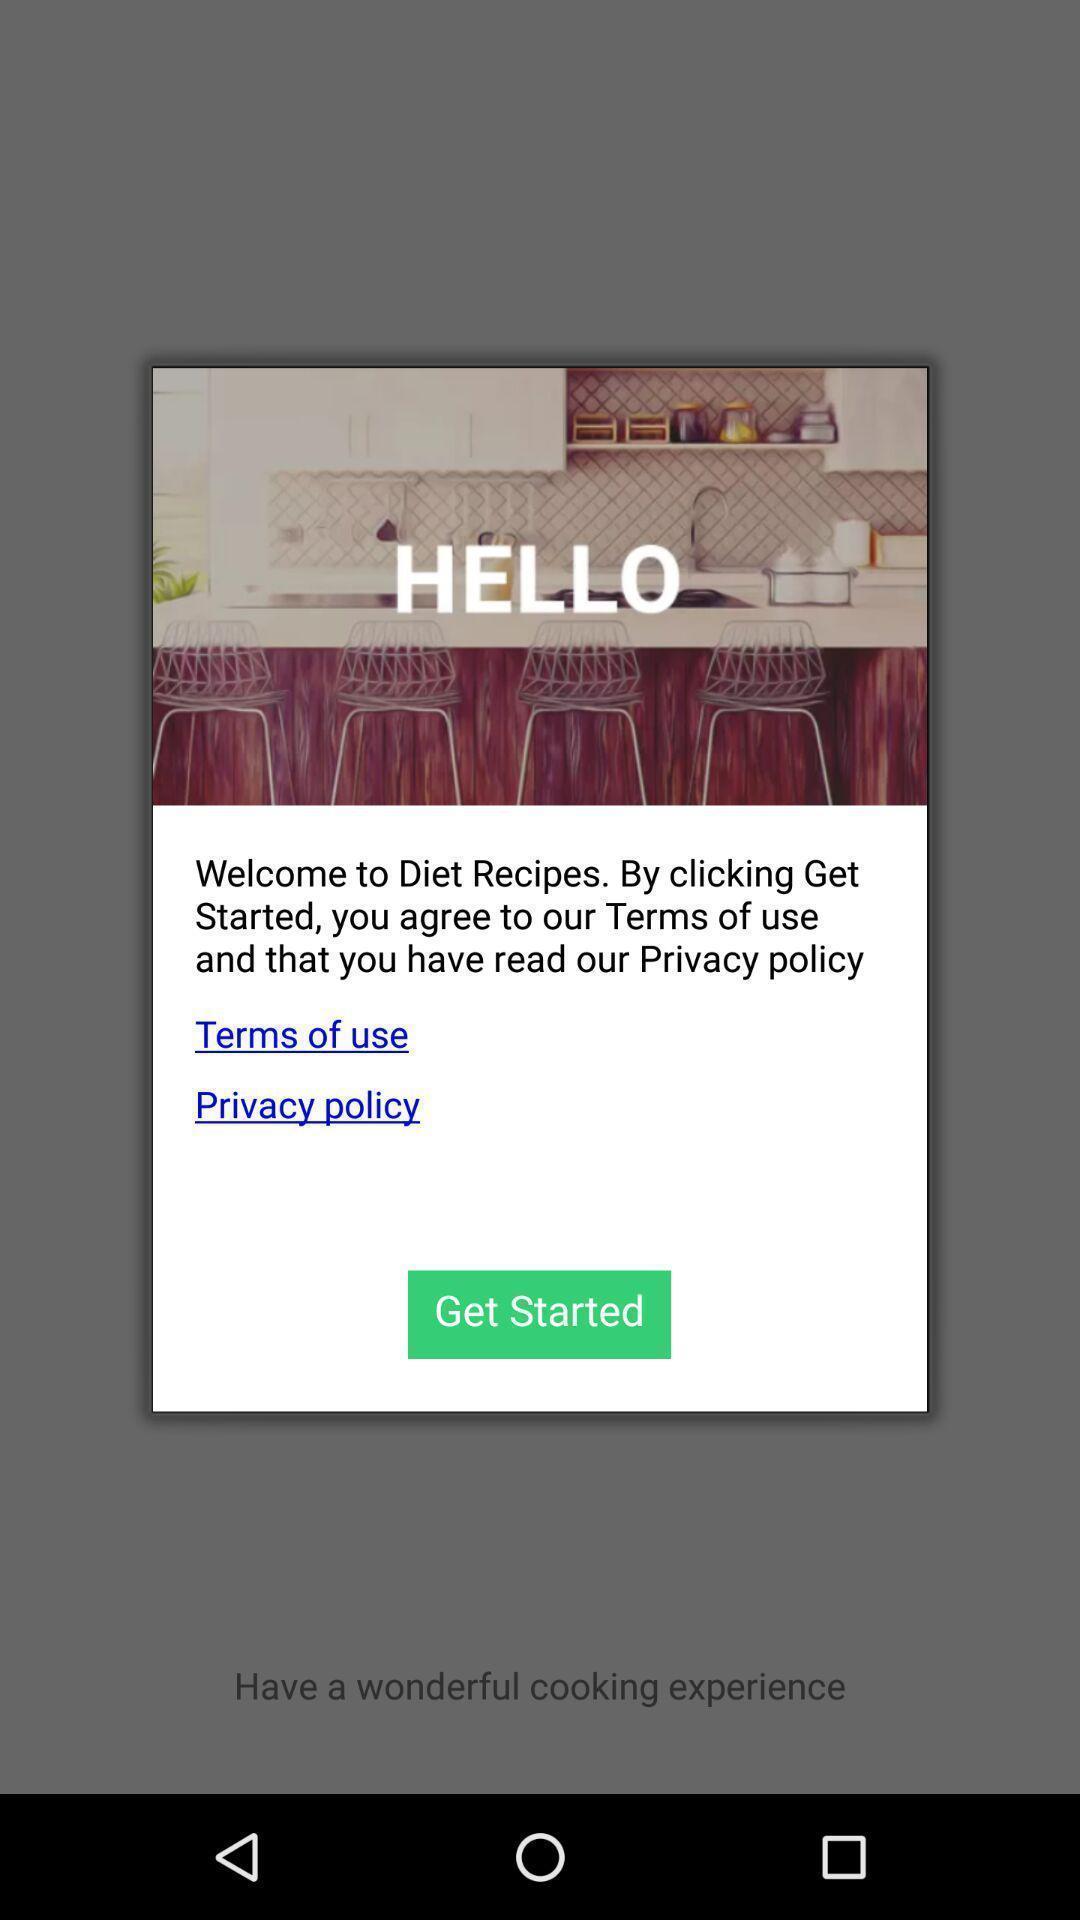Describe the key features of this screenshot. Popup page showing terms conditions for start. 